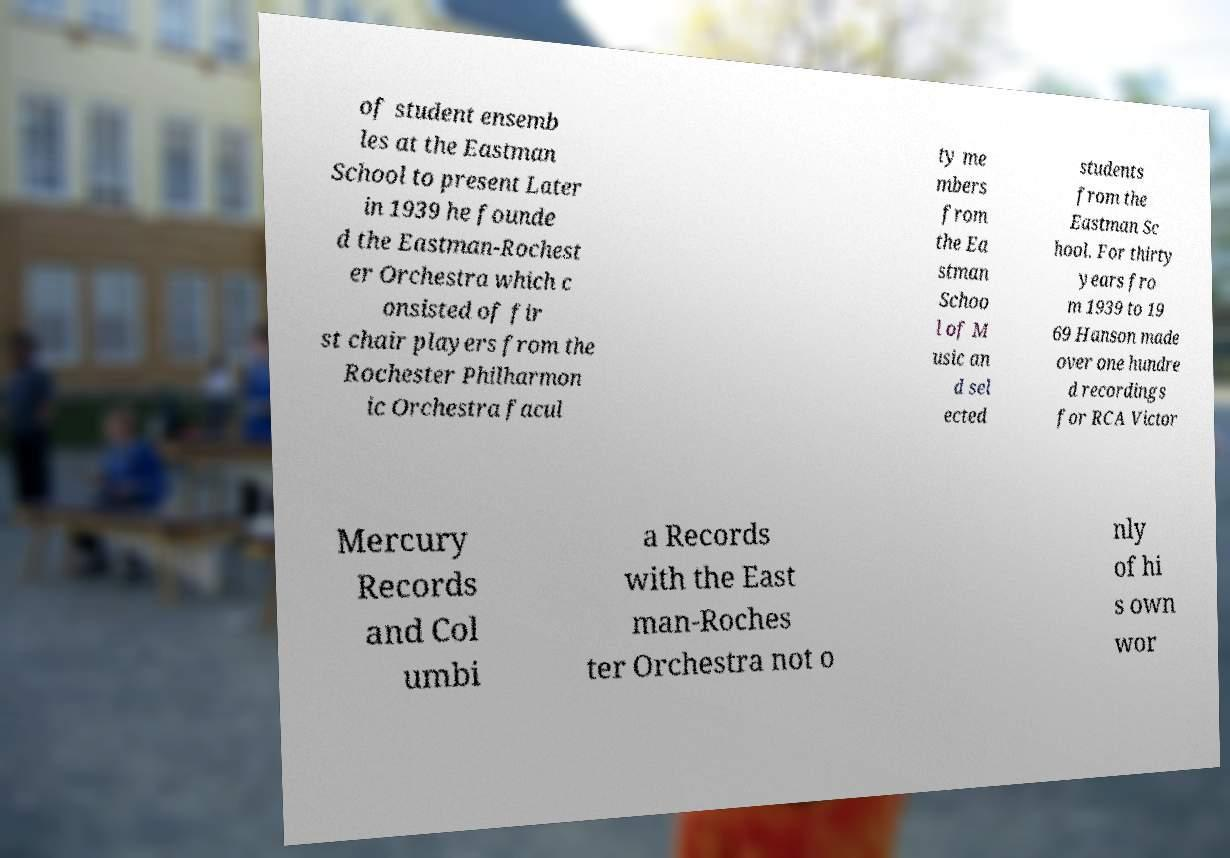Could you extract and type out the text from this image? of student ensemb les at the Eastman School to present Later in 1939 he founde d the Eastman-Rochest er Orchestra which c onsisted of fir st chair players from the Rochester Philharmon ic Orchestra facul ty me mbers from the Ea stman Schoo l of M usic an d sel ected students from the Eastman Sc hool. For thirty years fro m 1939 to 19 69 Hanson made over one hundre d recordings for RCA Victor Mercury Records and Col umbi a Records with the East man-Roches ter Orchestra not o nly of hi s own wor 